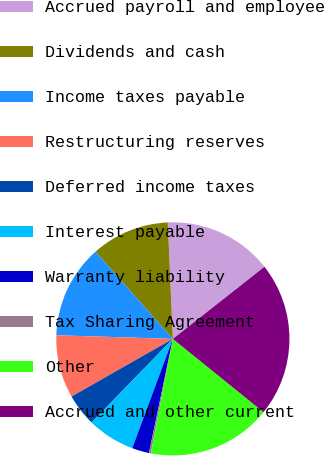Convert chart. <chart><loc_0><loc_0><loc_500><loc_500><pie_chart><fcel>Accrued payroll and employee<fcel>Dividends and cash<fcel>Income taxes payable<fcel>Restructuring reserves<fcel>Deferred income taxes<fcel>Interest payable<fcel>Warranty liability<fcel>Tax Sharing Agreement<fcel>Other<fcel>Accrued and other current<nl><fcel>15.08%<fcel>10.85%<fcel>12.96%<fcel>8.73%<fcel>4.49%<fcel>6.61%<fcel>2.38%<fcel>0.26%<fcel>17.2%<fcel>21.43%<nl></chart> 